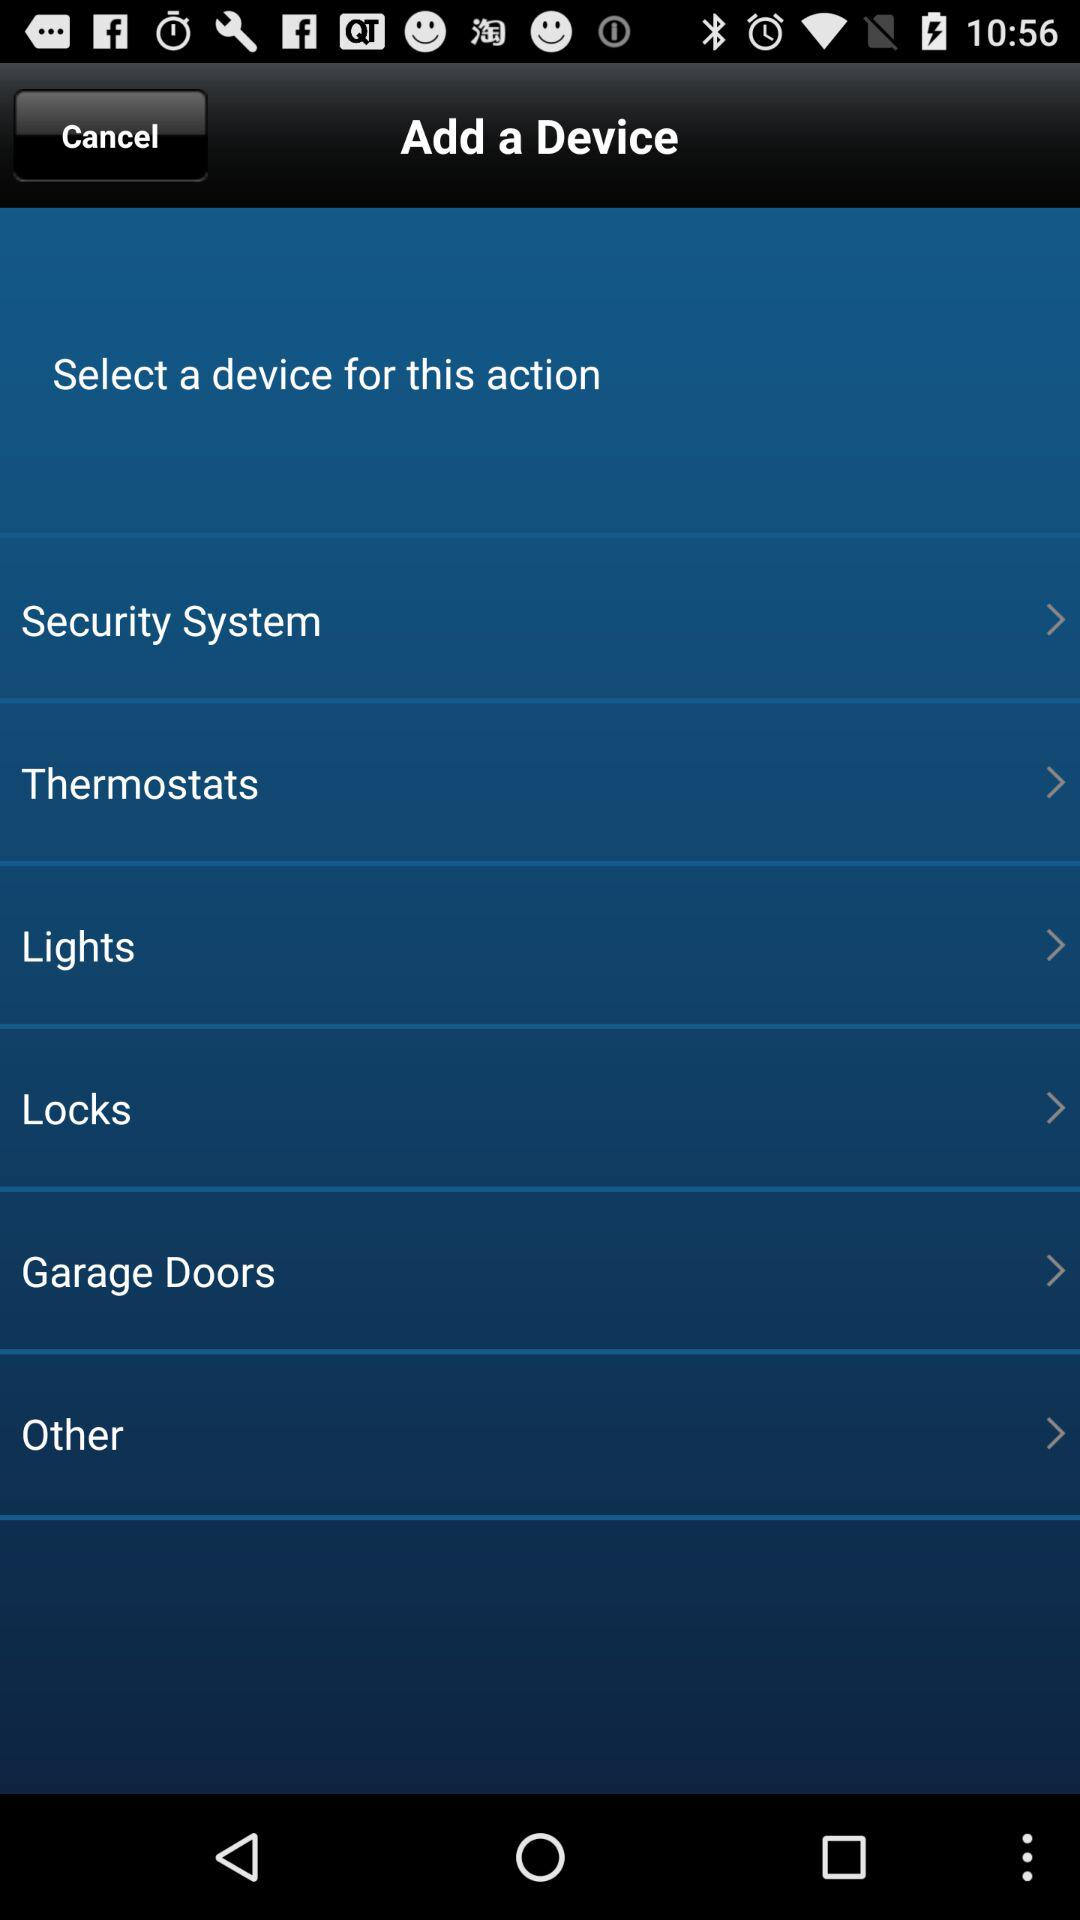How many devices are available for selection?
Answer the question using a single word or phrase. 6 